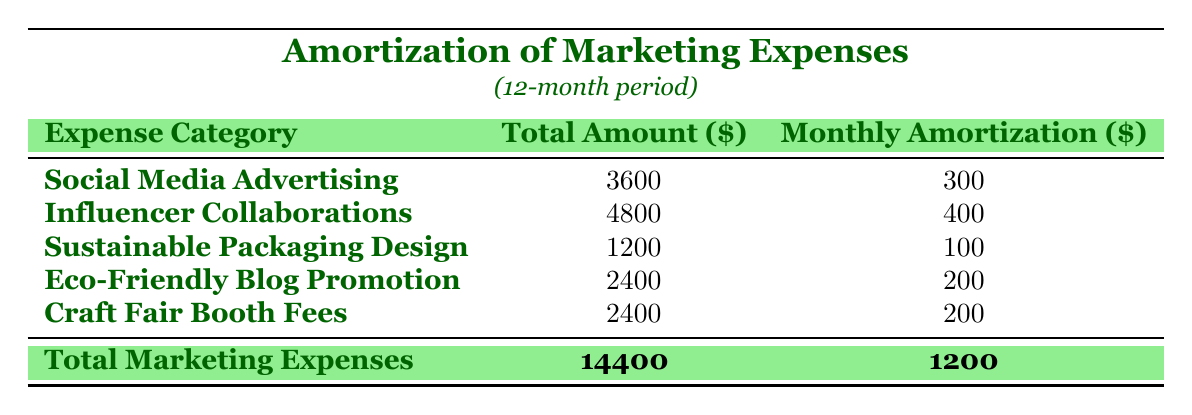What is the total amount for Social Media Advertising? The table shows that the Total Amount for Social Media Advertising is listed as 3600.
Answer: 3600 What is the Monthly Amortization for Influencer Collaborations? According to the table, the Monthly Amortization for Influencer Collaborations is 400.
Answer: 400 Is the Total Amount for Sustainable Packaging Design more than 1500? The Total Amount for Sustainable Packaging Design is 1200, which is not greater than 1500, making the answer false.
Answer: No What is the total Monthly Amortization for Craft Fair Booth Fees and Eco-Friendly Blog Promotion? The Monthly Amortization for Craft Fair Booth Fees is 200 and for Eco-Friendly Blog Promotion is also 200. Adding them gives 200 + 200 = 400.
Answer: 400 Which expense category has the highest Total Amount? By comparing the Total Amounts in the table, Influencer Collaborations has the highest value at 4800.
Answer: Influencer Collaborations What is the average Monthly Amortization for all marketing expenses? There are 5 categories, with a total Monthly Amortization of 1200. To find the average, divide 1200 by 5, resulting in 240.
Answer: 240 Is the combined amount for Social Media Advertising and Eco-Friendly Blog Promotion greater than 6000? The Total Amount for Social Media Advertising is 3600, and for Eco-Friendly Blog Promotion, it is 2400. Combining these gives 3600 + 2400 = 6000, which is not greater than 6000.
Answer: No What is the difference between the Total Amount of Influencer Collaborations and Sustainable Packaging Design? The Total Amount for Influencer Collaborations is 4800 and for Sustainable Packaging Design is 1200. The difference is 4800 - 1200 = 3600.
Answer: 3600 What percentage of the Total Marketing Expenses does Eco-Friendly Blog Promotion represent? The Total Marketing Expenses amount to 14400, and Eco-Friendly Blog Promotion is 2400. The percentage is calculated as (2400 / 14400) * 100 = 16.67%.
Answer: 16.67% 